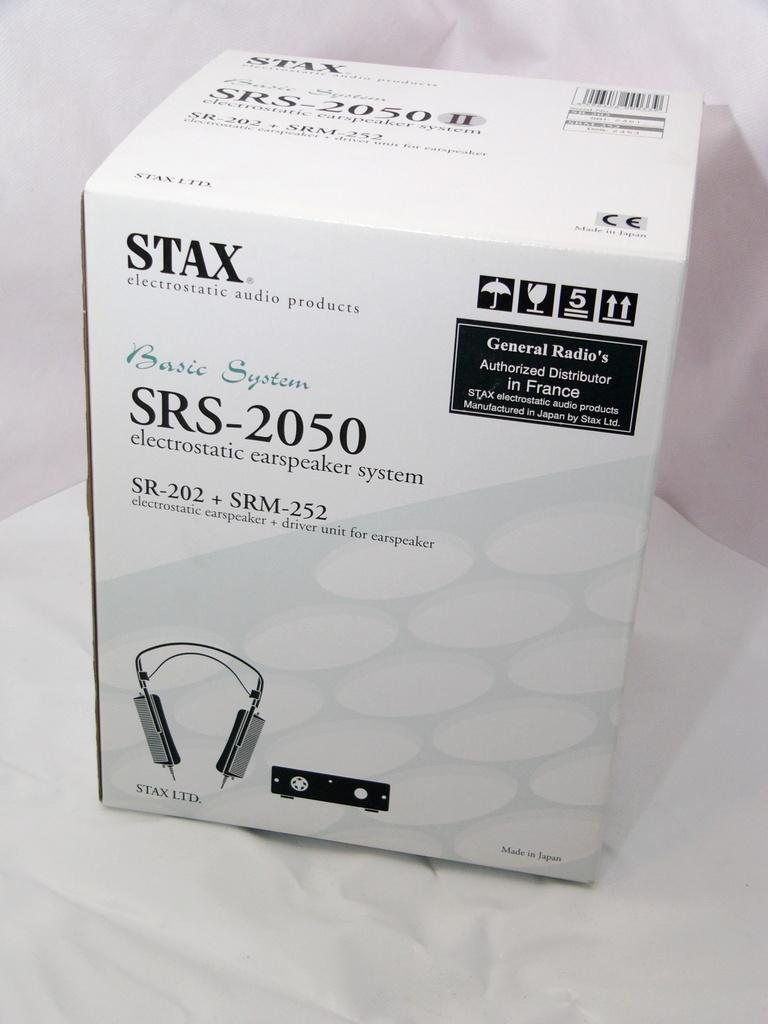<image>
Share a concise interpretation of the image provided. a box of stax electrostatic audio products labeled 'SRS-2050' 